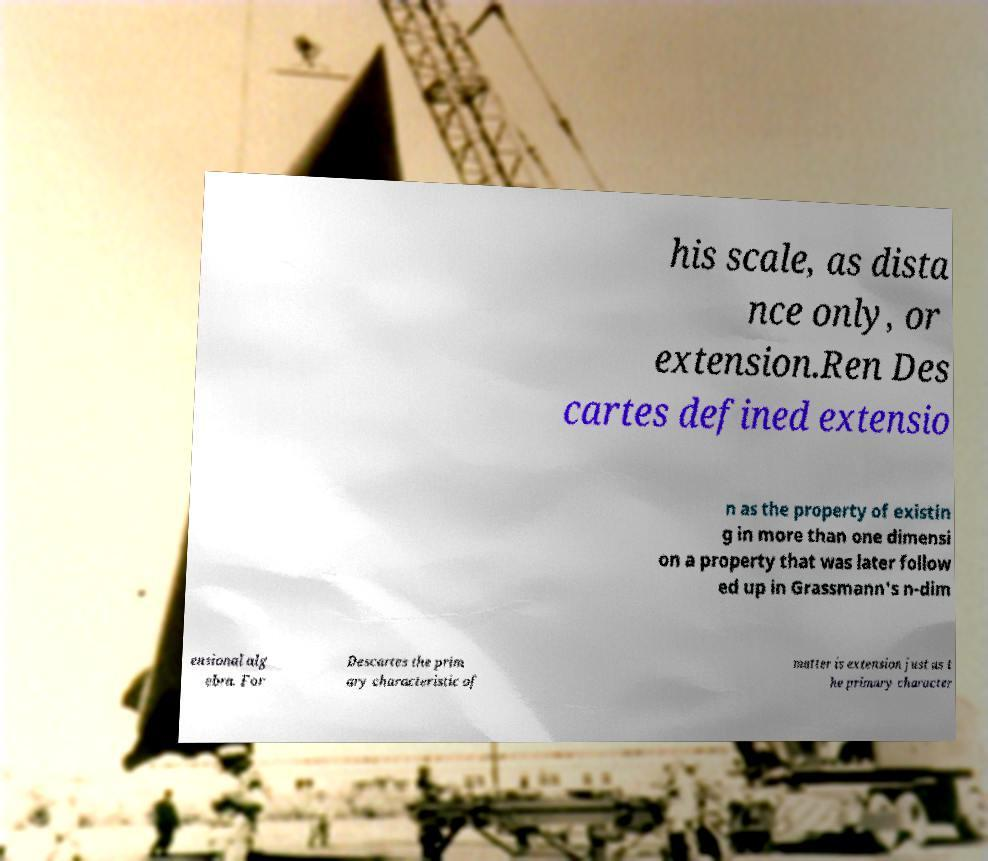Please read and relay the text visible in this image. What does it say? his scale, as dista nce only, or extension.Ren Des cartes defined extensio n as the property of existin g in more than one dimensi on a property that was later follow ed up in Grassmann's n-dim ensional alg ebra. For Descartes the prim ary characteristic of matter is extension just as t he primary character 